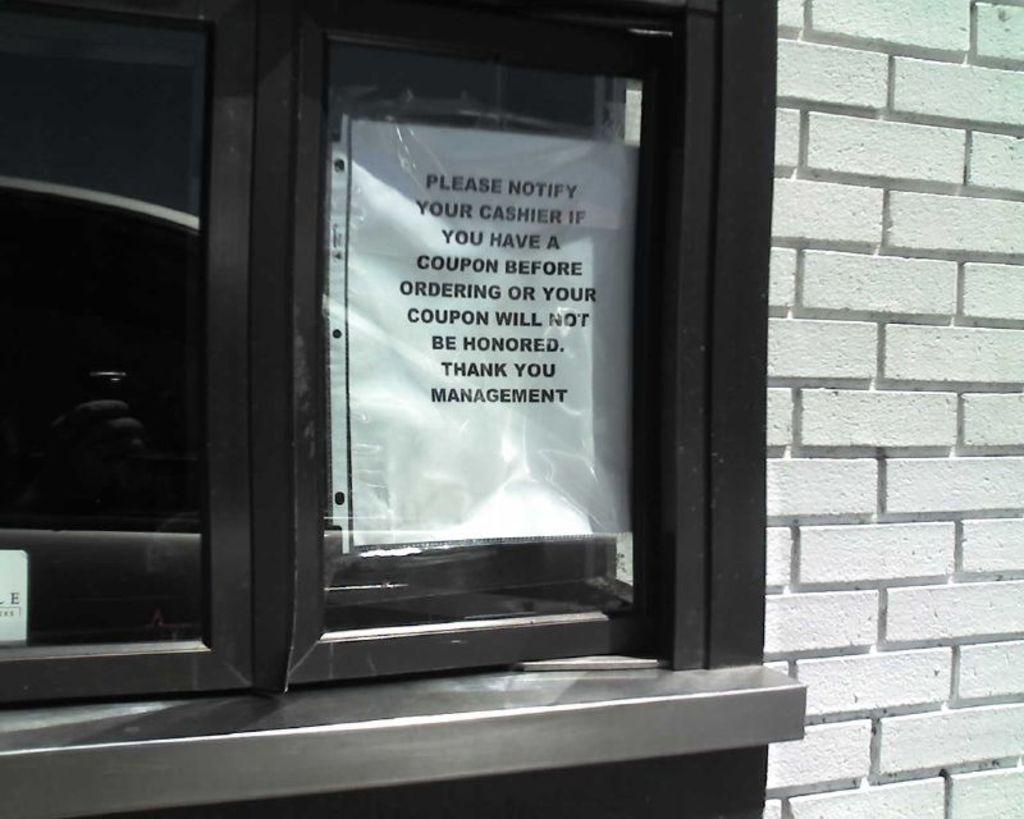<image>
Write a terse but informative summary of the picture. Posted on the window of a drive through is a message suggesting to notify your cashier if you have a coupon. 